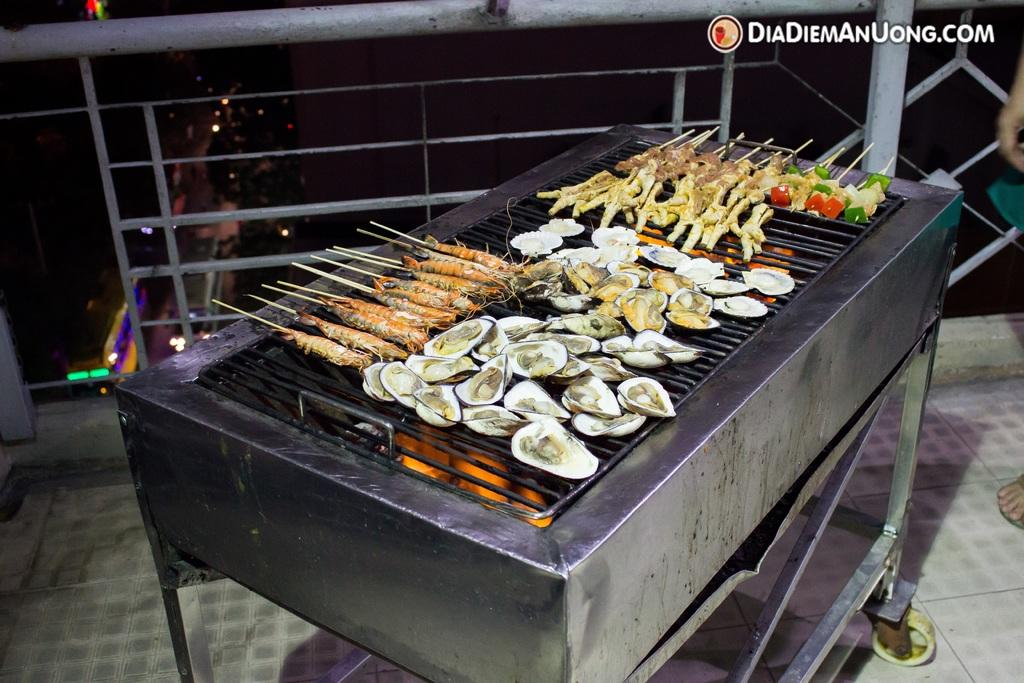<image>
Summarize the visual content of the image. a diadiemanuong.com image of a grill that is cooking 